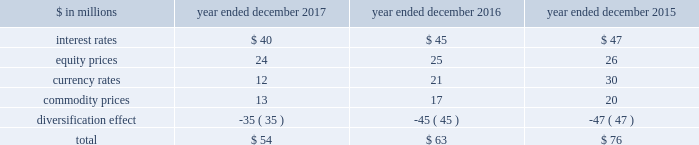The goldman sachs group , inc .
And subsidiaries management 2019s discussion and analysis the risk committee of the board and the risk governance committee ( through delegated authority from the firmwide risk committee ) approve market risk limits and sub-limits at firmwide , business and product levels , consistent with our risk appetite statement .
In addition , market risk management ( through delegated authority from the risk governance committee ) sets market risk limits and sub-limits at certain product and desk levels .
The purpose of the firmwide limits is to assist senior management in controlling our overall risk profile .
Sub-limits are set below the approved level of risk limits .
Sub-limits set the desired maximum amount of exposure that may be managed by any particular business on a day-to-day basis without additional levels of senior management approval , effectively leaving day-to-day decisions to individual desk managers and traders .
Accordingly , sub-limits are a management tool designed to ensure appropriate escalation rather than to establish maximum risk tolerance .
Sub-limits also distribute risk among various businesses in a manner that is consistent with their level of activity and client demand , taking into account the relative performance of each area .
Our market risk limits are monitored daily by market risk management , which is responsible for identifying and escalating , on a timely basis , instances where limits have been exceeded .
When a risk limit has been exceeded ( e.g. , due to positional changes or changes in market conditions , such as increased volatilities or changes in correlations ) , it is escalated to senior managers in market risk management and/or the appropriate risk committee .
Such instances are remediated by an inventory reduction and/or a temporary or permanent increase to the risk limit .
Model review and validation our var and stress testing models are regularly reviewed by market risk management and enhanced in order to incorporate changes in the composition of positions included in our market risk measures , as well as variations in market conditions .
Prior to implementing significant changes to our assumptions and/or models , model risk management performs model validations .
Significant changes to our var and stress testing models are reviewed with our chief risk officer and chief financial officer , and approved by the firmwide risk committee .
See 201cmodel risk management 201d for further information about the review and validation of these models .
Systems we have made a significant investment in technology to monitor market risk including : 2030 an independent calculation of var and stress measures ; 2030 risk measures calculated at individual position levels ; 2030 attribution of risk measures to individual risk factors of each position ; 2030 the ability to report many different views of the risk measures ( e.g. , by desk , business , product type or entity ) ; 2030 the ability to produce ad hoc analyses in a timely manner .
Metrics we analyze var at the firmwide level and a variety of more detailed levels , including by risk category , business , and region .
The tables below present average daily var and period-end var , as well as the high and low var for the period .
Diversification effect in the tables below represents the difference between total var and the sum of the vars for the four risk categories .
This effect arises because the four market risk categories are not perfectly correlated .
The table below presents average daily var by risk category. .
Our average daily var decreased to $ 54 million in 2017 from $ 63 million in 2016 , due to reductions across all risk categories , partially offset by a decrease in the diversification effect .
The overall decrease was primarily due to lower levels of volatility .
Our average daily var decreased to $ 63 million in 2016 from $ 76 million in 2015 , due to reductions across all risk categories , partially offset by a decrease in the diversification effect .
The overall decrease was primarily due to reduced exposures .
Goldman sachs 2017 form 10-k 91 .
In millions for 2016 , was the average daily var by risk category for impact of interest rates greater than equity prices? 
Computations: (45 > 25)
Answer: yes. 